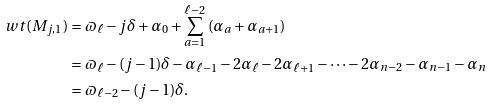<formula> <loc_0><loc_0><loc_500><loc_500>\ w t ( M _ { j , 1 } ) & = \varpi _ { \ell } - j \delta + \alpha _ { 0 } + \sum _ { a = 1 } ^ { \ell - 2 } \left ( \alpha _ { a } + \alpha _ { a + 1 } \right ) \\ & = \varpi _ { \ell } - ( j - 1 ) \delta - \alpha _ { \ell - 1 } - 2 \alpha _ { \ell } - 2 \alpha _ { \ell + 1 } - \cdots - 2 \alpha _ { n - 2 } - \alpha _ { n - 1 } - \alpha _ { n } \\ & = \varpi _ { \ell - 2 } - ( j - 1 ) \delta .</formula> 